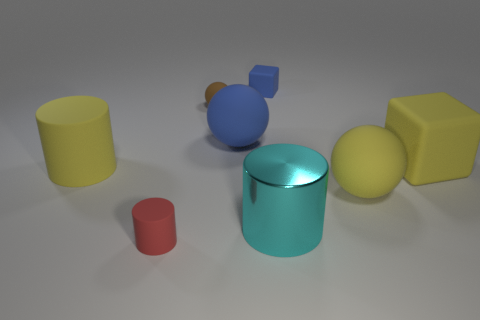Add 1 tiny blue rubber objects. How many objects exist? 9 Subtract all balls. How many objects are left? 5 Add 4 red rubber things. How many red rubber things exist? 5 Subtract 0 cyan balls. How many objects are left? 8 Subtract all big matte cylinders. Subtract all large yellow matte spheres. How many objects are left? 6 Add 5 small brown spheres. How many small brown spheres are left? 6 